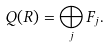<formula> <loc_0><loc_0><loc_500><loc_500>Q ( R ) = \bigoplus _ { j } F _ { j } .</formula> 